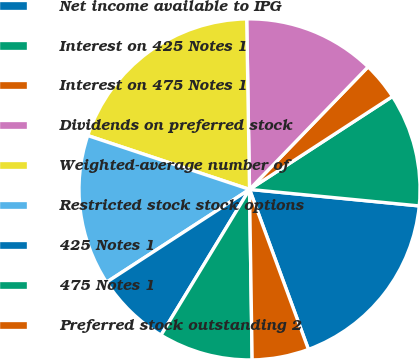Convert chart to OTSL. <chart><loc_0><loc_0><loc_500><loc_500><pie_chart><fcel>Net income available to IPG<fcel>Interest on 425 Notes 1<fcel>Interest on 475 Notes 1<fcel>Dividends on preferred stock<fcel>Weighted-average number of<fcel>Restricted stock stock options<fcel>425 Notes 1<fcel>475 Notes 1<fcel>Preferred stock outstanding 2<nl><fcel>17.84%<fcel>10.72%<fcel>3.59%<fcel>12.5%<fcel>19.62%<fcel>14.28%<fcel>7.15%<fcel>8.93%<fcel>5.37%<nl></chart> 